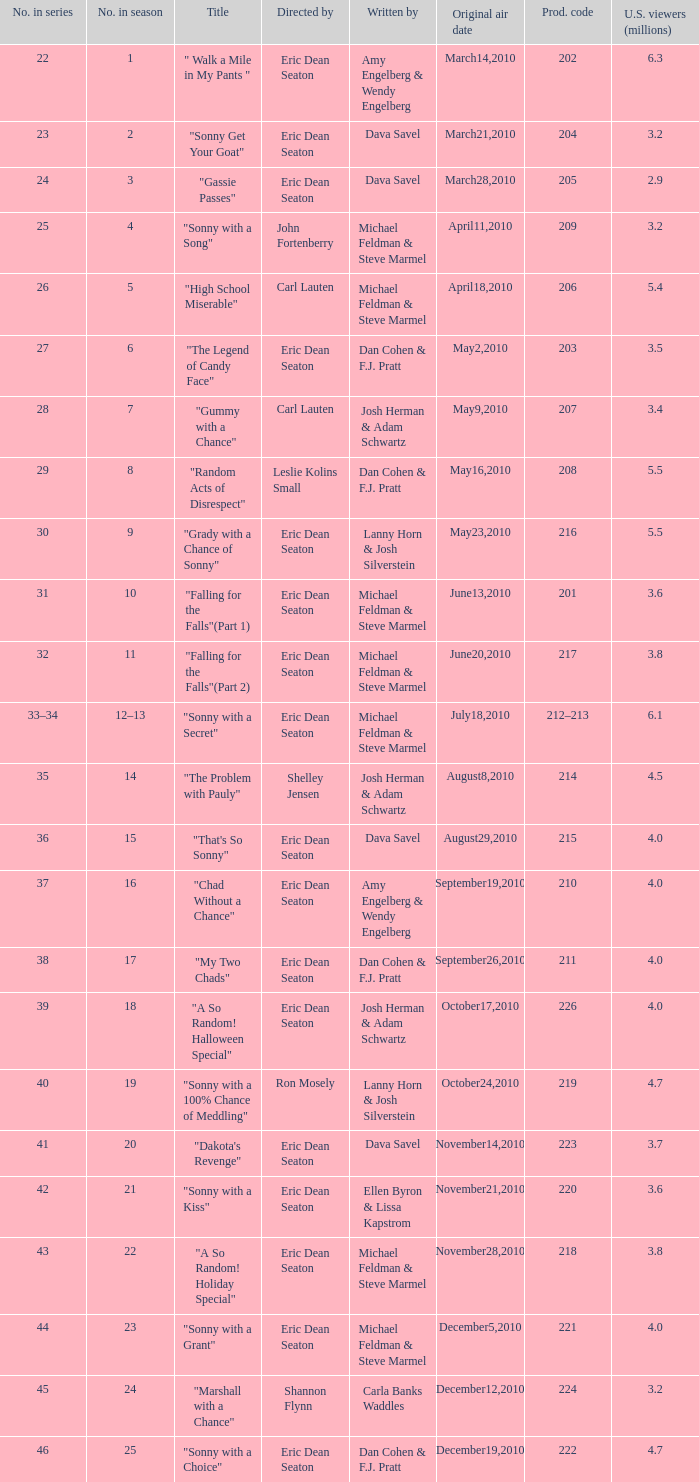How man episodes in the season were titled "that's so sonny"? 1.0. 